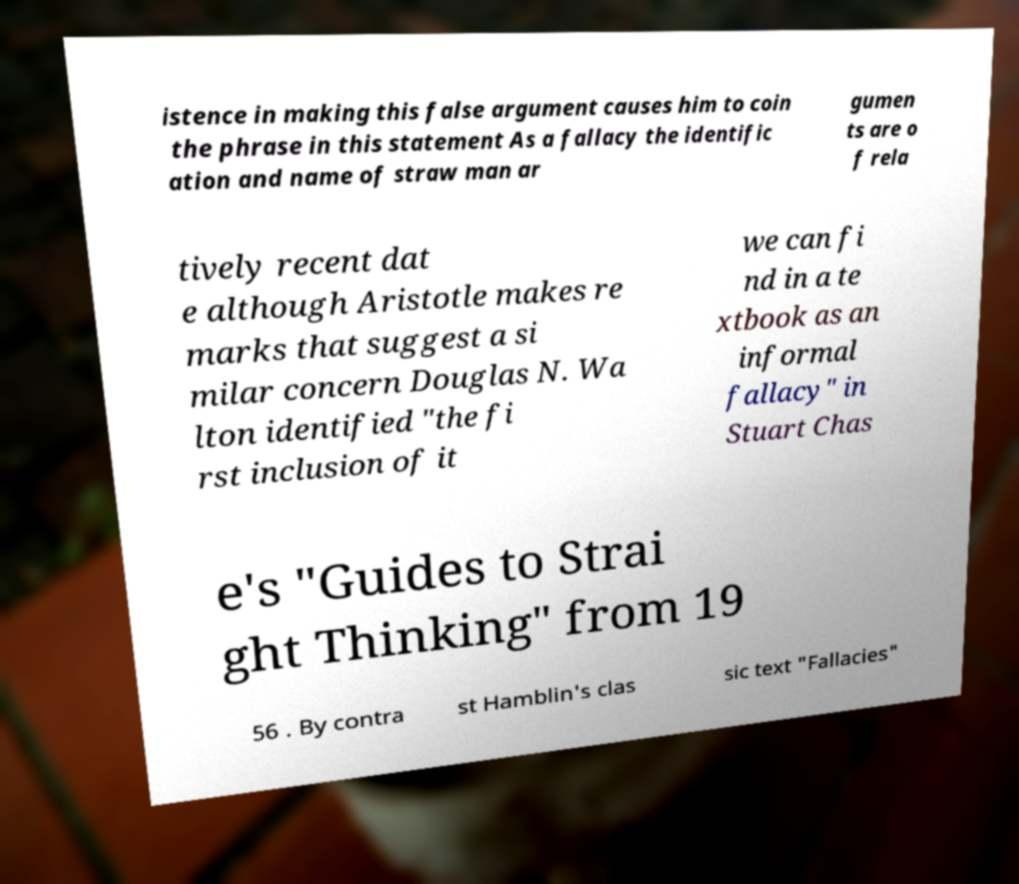Please read and relay the text visible in this image. What does it say? istence in making this false argument causes him to coin the phrase in this statement As a fallacy the identific ation and name of straw man ar gumen ts are o f rela tively recent dat e although Aristotle makes re marks that suggest a si milar concern Douglas N. Wa lton identified "the fi rst inclusion of it we can fi nd in a te xtbook as an informal fallacy" in Stuart Chas e's "Guides to Strai ght Thinking" from 19 56 . By contra st Hamblin's clas sic text "Fallacies" 